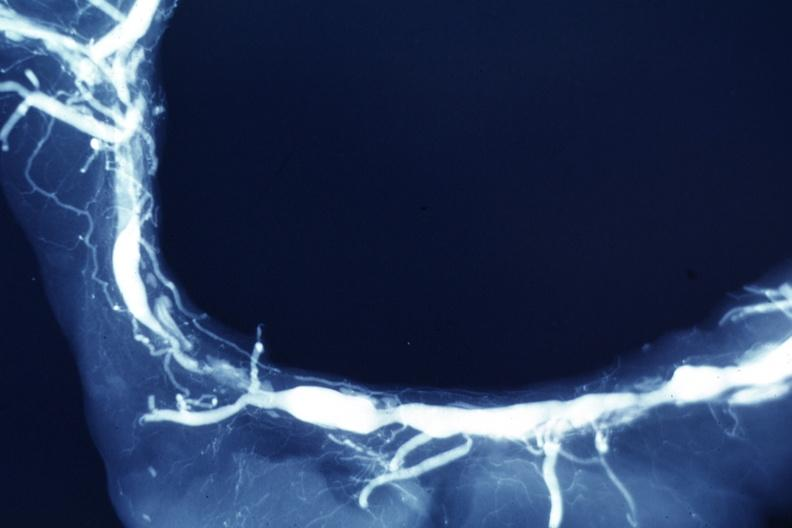what is present?
Answer the question using a single word or phrase. Vasculature 